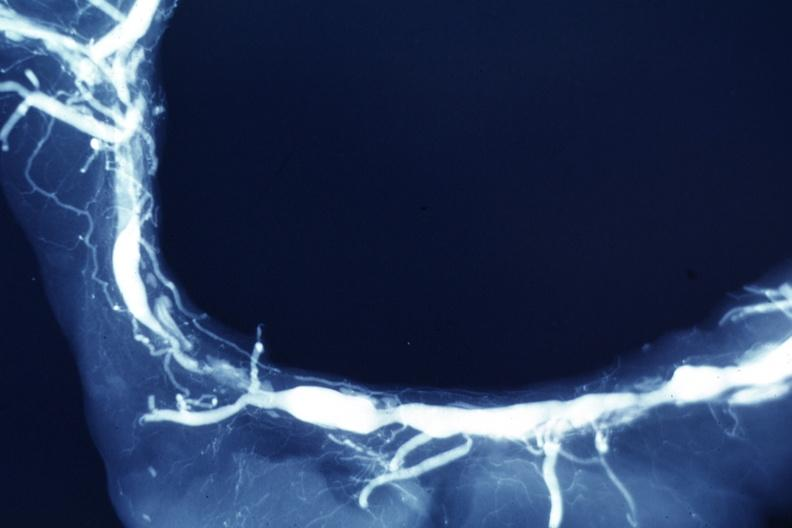what is present?
Answer the question using a single word or phrase. Vasculature 